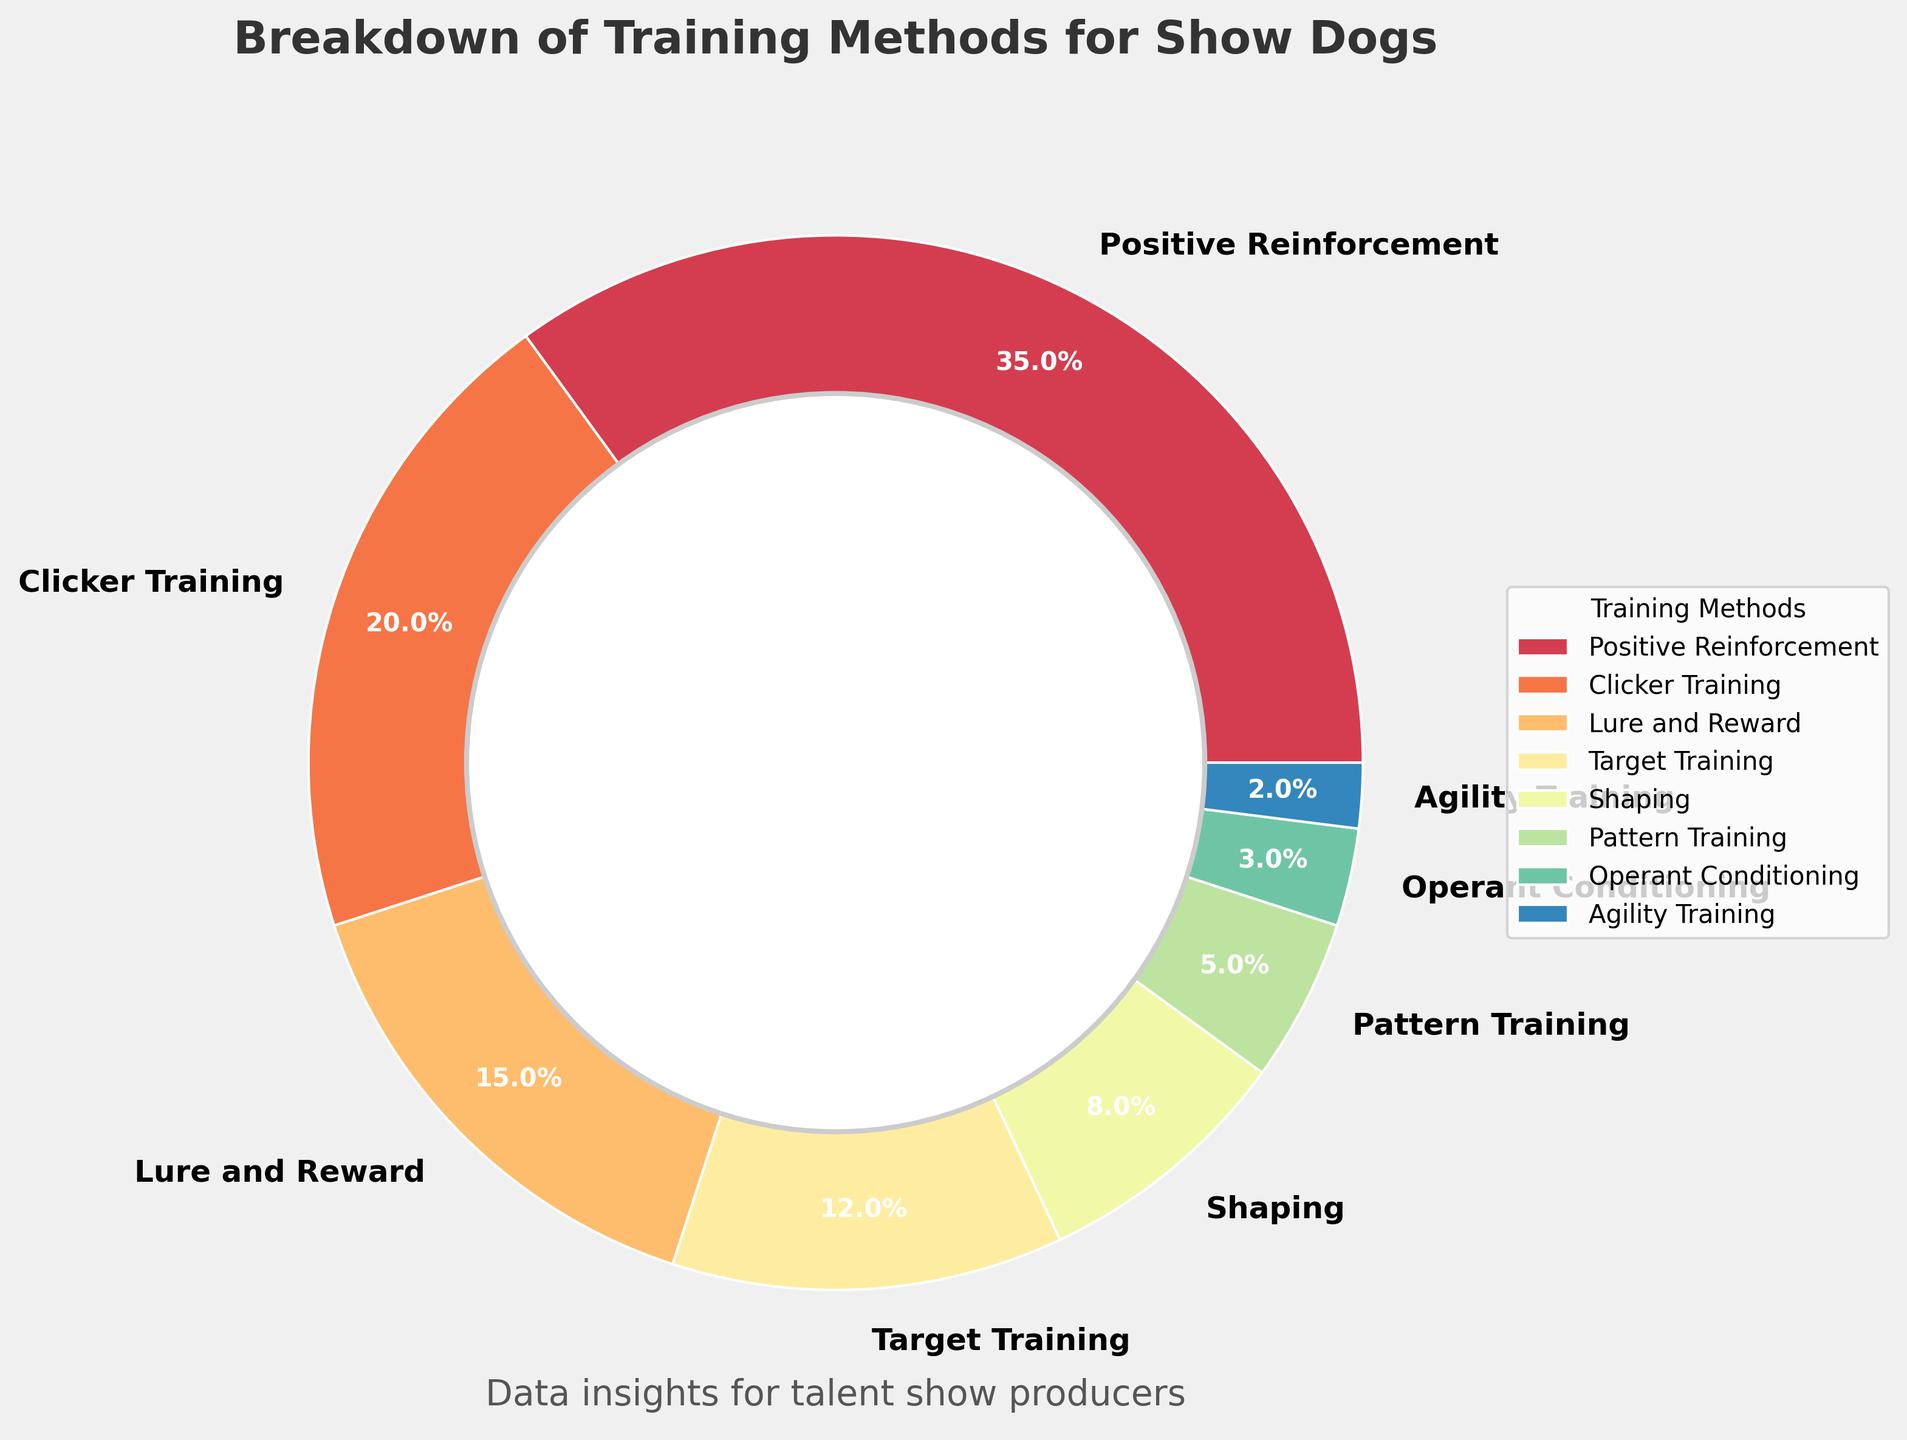What percentage of show dogs are trained using Positive Reinforcement? By examining the pie chart, locate the slice labeled "Positive Reinforcement" and read its corresponding percentage.
Answer: 35% Which training method is used by the least percentage of show dogs? Inspect the pie chart to find the smallest slice, which represents the training method with the lowest percentage.
Answer: Agility Training What is the sum of the percentages for Clicker Training and Lure and Reward? Find the percentages for Clicker Training (20%) and Lure and Reward (15%), then add them together: 20% + 15% = 35%.
Answer: 35% Is Target Training used by a greater percentage of show dogs than Shaping? Compare the slices labeled Target Training (12%) and Shaping (8%) to see which is larger.
Answer: Yes What three training methods are used by less than 10% of show dogs? Identify slices with percentages less than 10%, which are Shaping (8%), Pattern Training (5%), Operant Conditioning (3%), and Agility Training (2%). List the three with the lowest percentages.
Answer: Shaping, Pattern Training, Operant Conditioning Is the percentage of dogs trained using Positive Reinforcement more than twice the percentage trained using Clicker Training? First, determine if 35% (Positive Reinforcement) is more than twice 20% (Clicker Training). 2 * 20% = 40%, and 35% < 40%.
Answer: No How does the percentage of dogs trained using Lure and Reward compare to those trained using Target Training? Compare the percentages for Lure and Reward (15%) and Target Training (12%).
Answer: Lure and Reward is higher What is the combined percentage of dogs trained using Shaping and Pattern Training? Add the percentages for Shaping (8%) and Pattern Training (5%): 8% + 5% = 13%.
Answer: 13% Which two training methods have the closest percentages? Compare the percentages of all methods and identify the two that are numerically closest: Clicker Training (20%) and Lure and Reward (15%) differ by 5%.
Answer: Clicker Training and Lure and Reward If you group the training methods into those used by more than 10% of show dogs and those used by 10% or less, how many methods fall into each group? Identify methods with percentages greater than 10% (Positive Reinforcement, Clicker Training, Lure and Reward, Target Training) and those with 10% or less (Shaping, Pattern Training, Operant Conditioning, Agility Training). Count each group.
Answer: 4 methods in each group 